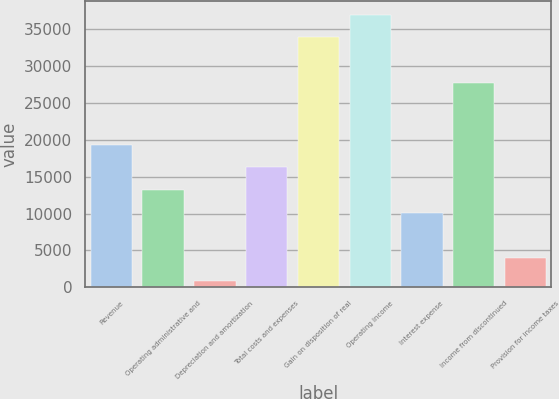Convert chart to OTSL. <chart><loc_0><loc_0><loc_500><loc_500><bar_chart><fcel>Revenue<fcel>Operating administrative and<fcel>Depreciation and amortization<fcel>Total costs and expenses<fcel>Gain on disposition of real<fcel>Operating income<fcel>Interest expense<fcel>Income from discontinued<fcel>Provision for income taxes<nl><fcel>19352.8<fcel>13195.2<fcel>880<fcel>16274<fcel>33924.4<fcel>37003.2<fcel>10116.4<fcel>27766.8<fcel>3958.8<nl></chart> 